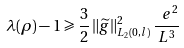<formula> <loc_0><loc_0><loc_500><loc_500>\lambda ( \rho ) - 1 \geqslant \frac { 3 } { 2 } \, \| \widetilde { g } \| _ { L _ { 2 } ( 0 , l ) } ^ { 2 } \, \frac { \ e ^ { 2 } } { L ^ { 3 } }</formula> 